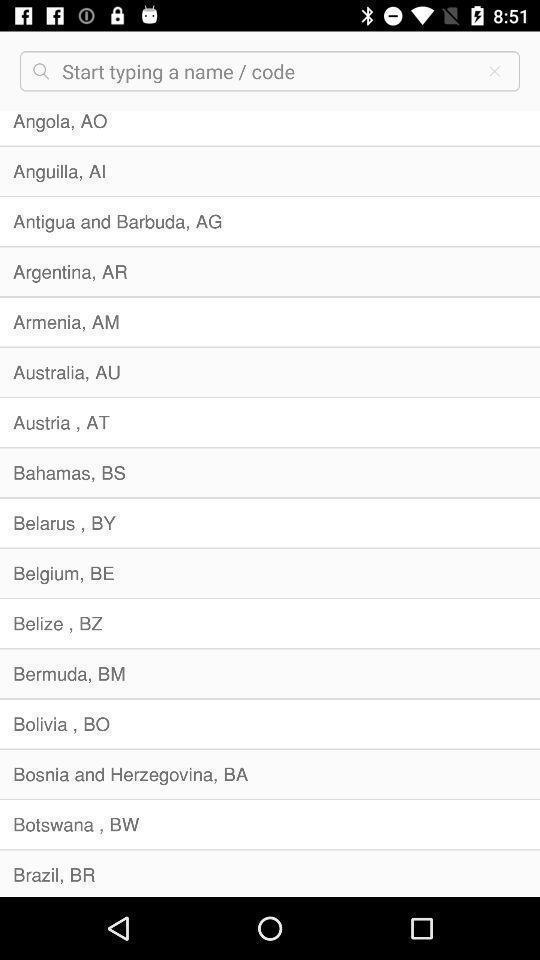Explain the elements present in this screenshot. Screen showing list of countries with search bar. 